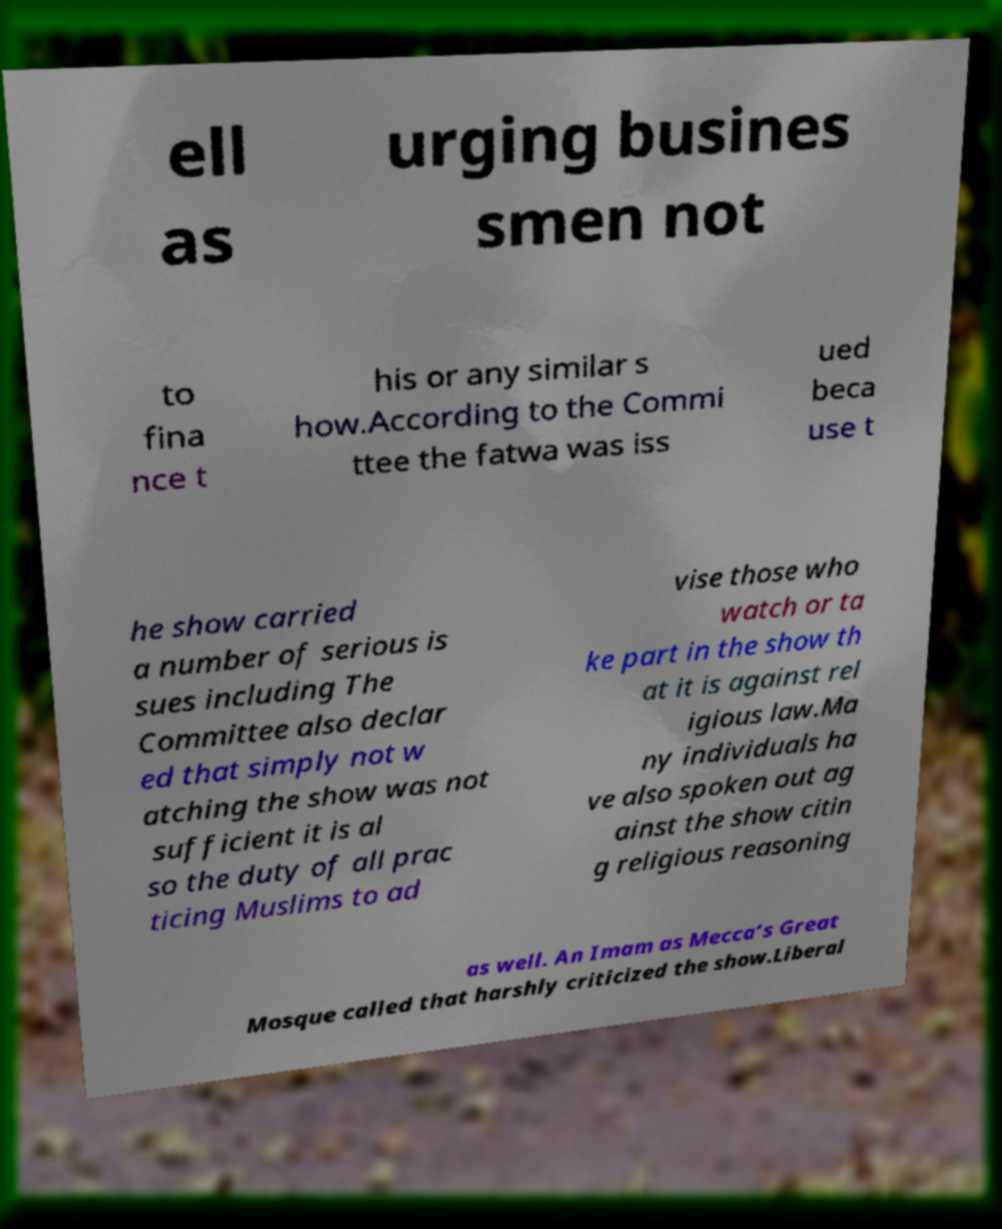Could you assist in decoding the text presented in this image and type it out clearly? ell as urging busines smen not to fina nce t his or any similar s how.According to the Commi ttee the fatwa was iss ued beca use t he show carried a number of serious is sues including The Committee also declar ed that simply not w atching the show was not sufficient it is al so the duty of all prac ticing Muslims to ad vise those who watch or ta ke part in the show th at it is against rel igious law.Ma ny individuals ha ve also spoken out ag ainst the show citin g religious reasoning as well. An Imam as Mecca’s Great Mosque called that harshly criticized the show.Liberal 